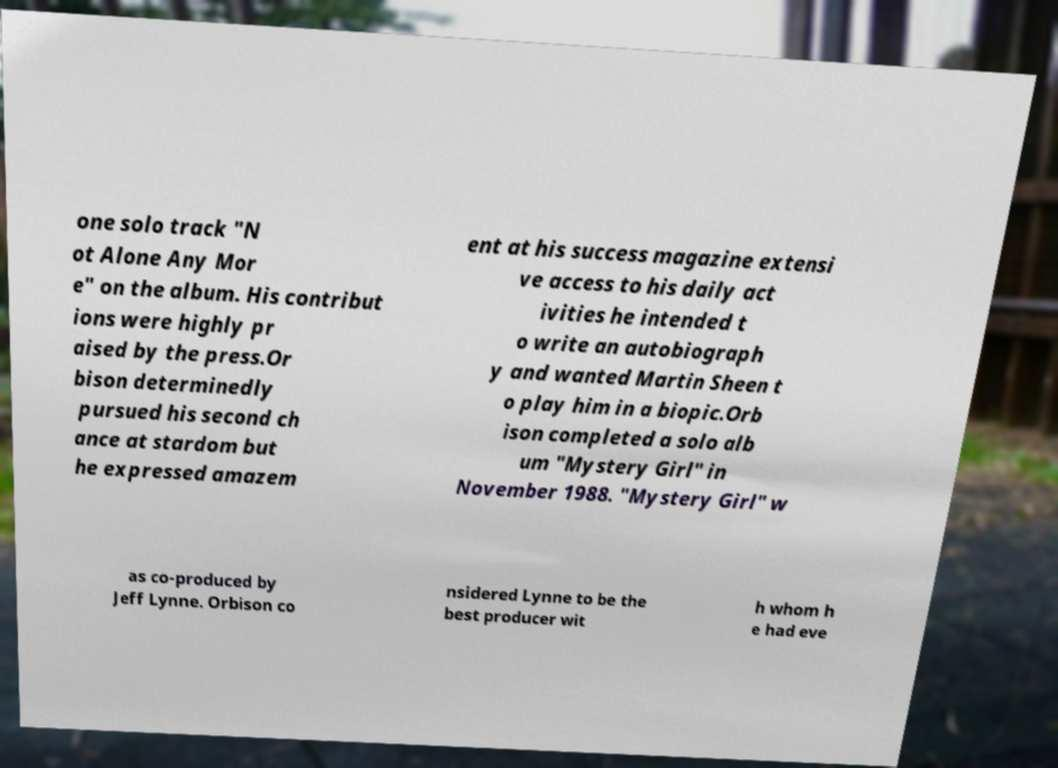There's text embedded in this image that I need extracted. Can you transcribe it verbatim? one solo track "N ot Alone Any Mor e" on the album. His contribut ions were highly pr aised by the press.Or bison determinedly pursued his second ch ance at stardom but he expressed amazem ent at his success magazine extensi ve access to his daily act ivities he intended t o write an autobiograph y and wanted Martin Sheen t o play him in a biopic.Orb ison completed a solo alb um "Mystery Girl" in November 1988. "Mystery Girl" w as co-produced by Jeff Lynne. Orbison co nsidered Lynne to be the best producer wit h whom h e had eve 